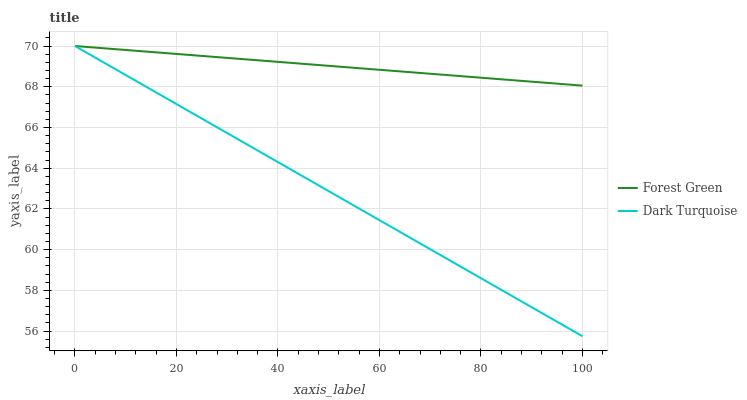Does Dark Turquoise have the minimum area under the curve?
Answer yes or no. Yes. Does Forest Green have the maximum area under the curve?
Answer yes or no. Yes. Does Forest Green have the minimum area under the curve?
Answer yes or no. No. Is Forest Green the smoothest?
Answer yes or no. Yes. Is Dark Turquoise the roughest?
Answer yes or no. Yes. Is Forest Green the roughest?
Answer yes or no. No. Does Dark Turquoise have the lowest value?
Answer yes or no. Yes. Does Forest Green have the lowest value?
Answer yes or no. No. Does Forest Green have the highest value?
Answer yes or no. Yes. Does Forest Green intersect Dark Turquoise?
Answer yes or no. Yes. Is Forest Green less than Dark Turquoise?
Answer yes or no. No. Is Forest Green greater than Dark Turquoise?
Answer yes or no. No. 